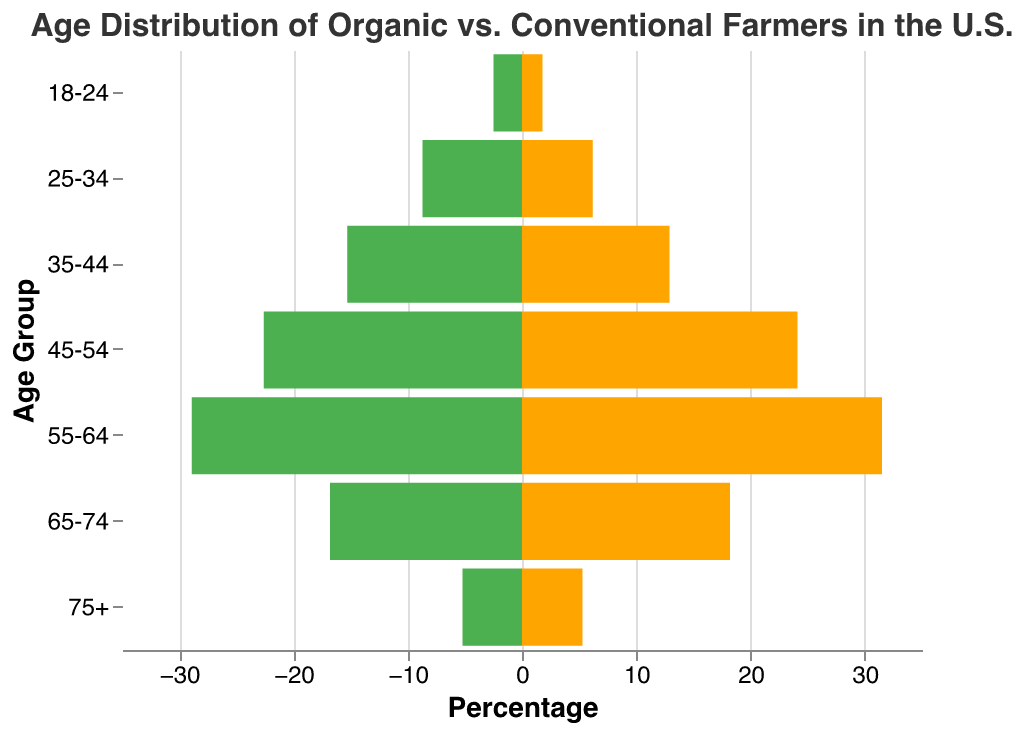What's the title of the figure? The title of the figure is displayed at the top center of the plot and reads "Age Distribution of Organic vs. Conventional Farmers in the U.S."
Answer: Age Distribution of Organic vs. Conventional Farmers in the U.S What's the percentage of organic farmers in the 55-64 age group? In the age group 55-64, the percentage for Organic Farmers is shown directly on the chart as 28.9%.
Answer: 28.9% How does the percentage of organic farmers in the 25-34 age group compare to conventional farmers in the same age group? To compare, look at the bars for the 25-34 age group: Organic Farmers are 8.7%, while Conventional Farmers are 6.2%. Organic Farmers have a higher percentage.
Answer: Organic Farmers Which age group has the highest percentage of conventional farmers? The highest percentage bar for Conventional Farmers is in the 55-64 age group, which is 31.5%.
Answer: 55-64 How many age groups have a higher percentage of organic farmers than conventional farmers? Compare each age group's bars for the two categories: 18-24, 25-34, and 35-44 age groups have higher percentages for Organic Farmers than Conventional Farmers.
Answer: 3 What's the percentage difference between organic and conventional farmers in the 35-44 age group? Subtract the percentage of Conventional Farmers (12.9%) from Organic Farmers (15.3%) in the 35-44 age group: 15.3% - 12.9% = 2.4%.
Answer: 2.4% Is there any age group where organic and conventional farmers have almost the same percentage? Check the bars: The age group 75+ has almost similar percentages; Organic Farmers are 5.2% and Conventional Farmers are 5.3%.
Answer: 75+ Which age group sees the greatest discrepancy between organic and conventional farmers, and what is that discrepancy? The greatest discrepancy is found in the 55-64 age group. Calculate the difference:
Answer: 2.6% 
    - For Organic Farmers: 28.9%
    - For Conventional Farmers: 31.5%
    - Discrepancy: 31.5% - 28.9% = 2.6% Are there more age groups where conventional farming percentages are greater than organic farming percentages or vice versa? Count the age groups for each comparison. There are more age groups (4) where conventional farming percentages are greater than organic farming percentages.
Answer: More age groups where conventional farming percentages are greater 